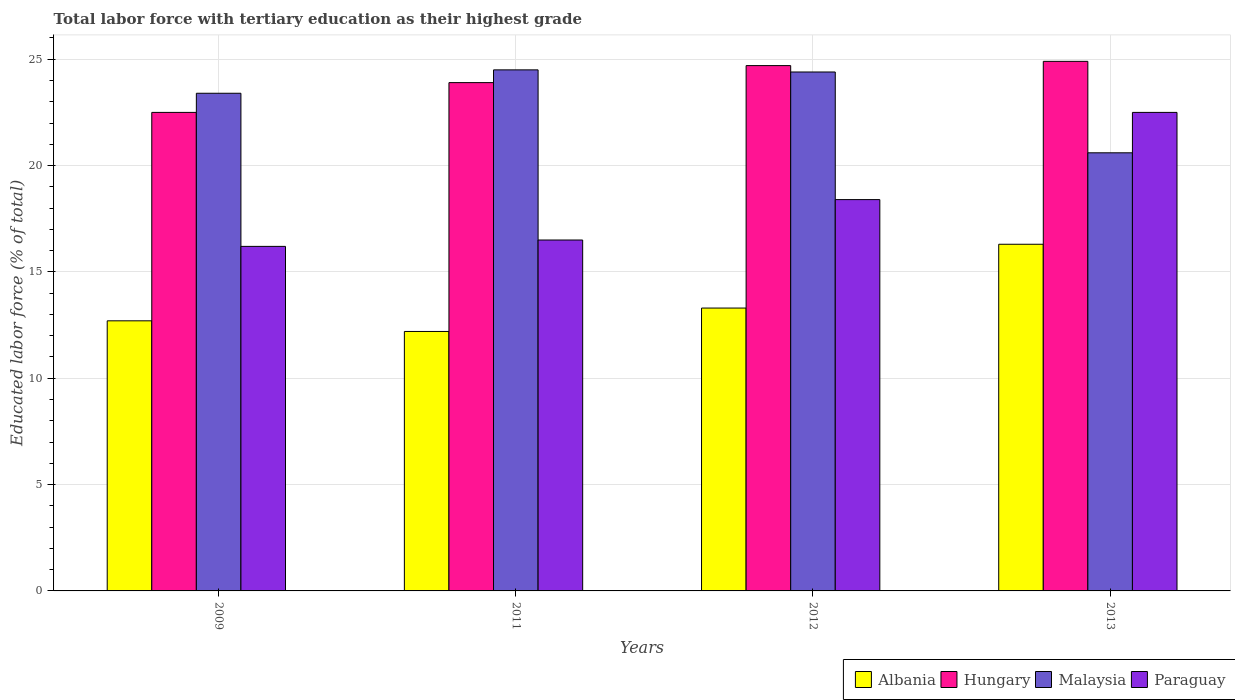How many different coloured bars are there?
Your answer should be very brief. 4. How many bars are there on the 3rd tick from the left?
Make the answer very short. 4. How many bars are there on the 1st tick from the right?
Give a very brief answer. 4. What is the label of the 2nd group of bars from the left?
Provide a short and direct response. 2011. What is the percentage of male labor force with tertiary education in Hungary in 2009?
Provide a succinct answer. 22.5. Across all years, what is the maximum percentage of male labor force with tertiary education in Hungary?
Your answer should be compact. 24.9. Across all years, what is the minimum percentage of male labor force with tertiary education in Albania?
Your response must be concise. 12.2. In which year was the percentage of male labor force with tertiary education in Hungary minimum?
Give a very brief answer. 2009. What is the total percentage of male labor force with tertiary education in Hungary in the graph?
Offer a very short reply. 96. What is the difference between the percentage of male labor force with tertiary education in Paraguay in 2011 and that in 2012?
Offer a very short reply. -1.9. What is the difference between the percentage of male labor force with tertiary education in Malaysia in 2009 and the percentage of male labor force with tertiary education in Albania in 2012?
Offer a terse response. 10.1. What is the average percentage of male labor force with tertiary education in Paraguay per year?
Keep it short and to the point. 18.4. In the year 2013, what is the difference between the percentage of male labor force with tertiary education in Hungary and percentage of male labor force with tertiary education in Malaysia?
Give a very brief answer. 4.3. What is the ratio of the percentage of male labor force with tertiary education in Hungary in 2011 to that in 2012?
Ensure brevity in your answer.  0.97. Is the percentage of male labor force with tertiary education in Hungary in 2011 less than that in 2013?
Keep it short and to the point. Yes. Is the difference between the percentage of male labor force with tertiary education in Hungary in 2009 and 2011 greater than the difference between the percentage of male labor force with tertiary education in Malaysia in 2009 and 2011?
Make the answer very short. No. What is the difference between the highest and the second highest percentage of male labor force with tertiary education in Hungary?
Provide a succinct answer. 0.2. What is the difference between the highest and the lowest percentage of male labor force with tertiary education in Albania?
Keep it short and to the point. 4.1. In how many years, is the percentage of male labor force with tertiary education in Paraguay greater than the average percentage of male labor force with tertiary education in Paraguay taken over all years?
Offer a very short reply. 1. What does the 2nd bar from the left in 2009 represents?
Provide a succinct answer. Hungary. What does the 3rd bar from the right in 2013 represents?
Your answer should be very brief. Hungary. How many bars are there?
Your response must be concise. 16. Are all the bars in the graph horizontal?
Provide a succinct answer. No. How many years are there in the graph?
Your answer should be very brief. 4. What is the difference between two consecutive major ticks on the Y-axis?
Provide a short and direct response. 5. Does the graph contain any zero values?
Give a very brief answer. No. How are the legend labels stacked?
Your response must be concise. Horizontal. What is the title of the graph?
Provide a succinct answer. Total labor force with tertiary education as their highest grade. Does "Croatia" appear as one of the legend labels in the graph?
Provide a succinct answer. No. What is the label or title of the Y-axis?
Provide a succinct answer. Educated labor force (% of total). What is the Educated labor force (% of total) in Albania in 2009?
Keep it short and to the point. 12.7. What is the Educated labor force (% of total) of Hungary in 2009?
Keep it short and to the point. 22.5. What is the Educated labor force (% of total) of Malaysia in 2009?
Provide a succinct answer. 23.4. What is the Educated labor force (% of total) in Paraguay in 2009?
Offer a very short reply. 16.2. What is the Educated labor force (% of total) in Albania in 2011?
Offer a very short reply. 12.2. What is the Educated labor force (% of total) of Hungary in 2011?
Provide a short and direct response. 23.9. What is the Educated labor force (% of total) of Malaysia in 2011?
Provide a succinct answer. 24.5. What is the Educated labor force (% of total) in Albania in 2012?
Your answer should be compact. 13.3. What is the Educated labor force (% of total) in Hungary in 2012?
Offer a very short reply. 24.7. What is the Educated labor force (% of total) in Malaysia in 2012?
Give a very brief answer. 24.4. What is the Educated labor force (% of total) in Paraguay in 2012?
Give a very brief answer. 18.4. What is the Educated labor force (% of total) in Albania in 2013?
Ensure brevity in your answer.  16.3. What is the Educated labor force (% of total) of Hungary in 2013?
Offer a terse response. 24.9. What is the Educated labor force (% of total) of Malaysia in 2013?
Your response must be concise. 20.6. Across all years, what is the maximum Educated labor force (% of total) in Albania?
Your response must be concise. 16.3. Across all years, what is the maximum Educated labor force (% of total) in Hungary?
Your answer should be compact. 24.9. Across all years, what is the minimum Educated labor force (% of total) of Albania?
Ensure brevity in your answer.  12.2. Across all years, what is the minimum Educated labor force (% of total) of Malaysia?
Provide a short and direct response. 20.6. Across all years, what is the minimum Educated labor force (% of total) of Paraguay?
Offer a terse response. 16.2. What is the total Educated labor force (% of total) in Albania in the graph?
Ensure brevity in your answer.  54.5. What is the total Educated labor force (% of total) of Hungary in the graph?
Provide a short and direct response. 96. What is the total Educated labor force (% of total) in Malaysia in the graph?
Your answer should be very brief. 92.9. What is the total Educated labor force (% of total) of Paraguay in the graph?
Ensure brevity in your answer.  73.6. What is the difference between the Educated labor force (% of total) of Hungary in 2009 and that in 2011?
Make the answer very short. -1.4. What is the difference between the Educated labor force (% of total) of Albania in 2009 and that in 2012?
Your answer should be very brief. -0.6. What is the difference between the Educated labor force (% of total) in Paraguay in 2009 and that in 2013?
Ensure brevity in your answer.  -6.3. What is the difference between the Educated labor force (% of total) in Albania in 2011 and that in 2012?
Your answer should be very brief. -1.1. What is the difference between the Educated labor force (% of total) in Hungary in 2011 and that in 2012?
Ensure brevity in your answer.  -0.8. What is the difference between the Educated labor force (% of total) of Paraguay in 2011 and that in 2012?
Provide a short and direct response. -1.9. What is the difference between the Educated labor force (% of total) in Albania in 2011 and that in 2013?
Offer a very short reply. -4.1. What is the difference between the Educated labor force (% of total) of Hungary in 2011 and that in 2013?
Your response must be concise. -1. What is the difference between the Educated labor force (% of total) in Malaysia in 2011 and that in 2013?
Ensure brevity in your answer.  3.9. What is the difference between the Educated labor force (% of total) in Paraguay in 2011 and that in 2013?
Give a very brief answer. -6. What is the difference between the Educated labor force (% of total) in Albania in 2012 and that in 2013?
Give a very brief answer. -3. What is the difference between the Educated labor force (% of total) in Malaysia in 2012 and that in 2013?
Your response must be concise. 3.8. What is the difference between the Educated labor force (% of total) in Albania in 2009 and the Educated labor force (% of total) in Hungary in 2011?
Offer a terse response. -11.2. What is the difference between the Educated labor force (% of total) in Albania in 2009 and the Educated labor force (% of total) in Malaysia in 2011?
Ensure brevity in your answer.  -11.8. What is the difference between the Educated labor force (% of total) of Albania in 2009 and the Educated labor force (% of total) of Paraguay in 2011?
Your answer should be very brief. -3.8. What is the difference between the Educated labor force (% of total) of Hungary in 2009 and the Educated labor force (% of total) of Malaysia in 2011?
Offer a very short reply. -2. What is the difference between the Educated labor force (% of total) in Malaysia in 2009 and the Educated labor force (% of total) in Paraguay in 2011?
Ensure brevity in your answer.  6.9. What is the difference between the Educated labor force (% of total) in Albania in 2009 and the Educated labor force (% of total) in Paraguay in 2012?
Offer a terse response. -5.7. What is the difference between the Educated labor force (% of total) in Hungary in 2009 and the Educated labor force (% of total) in Malaysia in 2012?
Your answer should be very brief. -1.9. What is the difference between the Educated labor force (% of total) in Hungary in 2009 and the Educated labor force (% of total) in Paraguay in 2012?
Your answer should be very brief. 4.1. What is the difference between the Educated labor force (% of total) of Albania in 2009 and the Educated labor force (% of total) of Malaysia in 2013?
Your answer should be very brief. -7.9. What is the difference between the Educated labor force (% of total) of Albania in 2011 and the Educated labor force (% of total) of Malaysia in 2012?
Offer a terse response. -12.2. What is the difference between the Educated labor force (% of total) in Albania in 2011 and the Educated labor force (% of total) in Paraguay in 2012?
Your answer should be very brief. -6.2. What is the difference between the Educated labor force (% of total) of Hungary in 2011 and the Educated labor force (% of total) of Malaysia in 2012?
Your answer should be very brief. -0.5. What is the difference between the Educated labor force (% of total) in Hungary in 2011 and the Educated labor force (% of total) in Malaysia in 2013?
Make the answer very short. 3.3. What is the difference between the Educated labor force (% of total) of Hungary in 2011 and the Educated labor force (% of total) of Paraguay in 2013?
Offer a terse response. 1.4. What is the difference between the Educated labor force (% of total) of Albania in 2012 and the Educated labor force (% of total) of Hungary in 2013?
Offer a very short reply. -11.6. What is the difference between the Educated labor force (% of total) in Albania in 2012 and the Educated labor force (% of total) in Malaysia in 2013?
Your answer should be very brief. -7.3. What is the difference between the Educated labor force (% of total) of Albania in 2012 and the Educated labor force (% of total) of Paraguay in 2013?
Provide a short and direct response. -9.2. What is the difference between the Educated labor force (% of total) of Hungary in 2012 and the Educated labor force (% of total) of Malaysia in 2013?
Your response must be concise. 4.1. What is the difference between the Educated labor force (% of total) in Hungary in 2012 and the Educated labor force (% of total) in Paraguay in 2013?
Your answer should be compact. 2.2. What is the difference between the Educated labor force (% of total) of Malaysia in 2012 and the Educated labor force (% of total) of Paraguay in 2013?
Provide a short and direct response. 1.9. What is the average Educated labor force (% of total) in Albania per year?
Provide a succinct answer. 13.62. What is the average Educated labor force (% of total) of Malaysia per year?
Provide a short and direct response. 23.23. What is the average Educated labor force (% of total) of Paraguay per year?
Provide a short and direct response. 18.4. In the year 2009, what is the difference between the Educated labor force (% of total) in Albania and Educated labor force (% of total) in Hungary?
Make the answer very short. -9.8. In the year 2009, what is the difference between the Educated labor force (% of total) of Albania and Educated labor force (% of total) of Paraguay?
Provide a short and direct response. -3.5. In the year 2009, what is the difference between the Educated labor force (% of total) in Hungary and Educated labor force (% of total) in Malaysia?
Your answer should be compact. -0.9. In the year 2009, what is the difference between the Educated labor force (% of total) of Hungary and Educated labor force (% of total) of Paraguay?
Your answer should be very brief. 6.3. In the year 2009, what is the difference between the Educated labor force (% of total) in Malaysia and Educated labor force (% of total) in Paraguay?
Keep it short and to the point. 7.2. In the year 2011, what is the difference between the Educated labor force (% of total) of Albania and Educated labor force (% of total) of Hungary?
Offer a terse response. -11.7. In the year 2011, what is the difference between the Educated labor force (% of total) of Hungary and Educated labor force (% of total) of Malaysia?
Offer a terse response. -0.6. In the year 2012, what is the difference between the Educated labor force (% of total) of Albania and Educated labor force (% of total) of Malaysia?
Your answer should be very brief. -11.1. In the year 2013, what is the difference between the Educated labor force (% of total) in Hungary and Educated labor force (% of total) in Malaysia?
Make the answer very short. 4.3. In the year 2013, what is the difference between the Educated labor force (% of total) of Hungary and Educated labor force (% of total) of Paraguay?
Give a very brief answer. 2.4. What is the ratio of the Educated labor force (% of total) in Albania in 2009 to that in 2011?
Give a very brief answer. 1.04. What is the ratio of the Educated labor force (% of total) of Hungary in 2009 to that in 2011?
Ensure brevity in your answer.  0.94. What is the ratio of the Educated labor force (% of total) of Malaysia in 2009 to that in 2011?
Your answer should be compact. 0.96. What is the ratio of the Educated labor force (% of total) of Paraguay in 2009 to that in 2011?
Make the answer very short. 0.98. What is the ratio of the Educated labor force (% of total) in Albania in 2009 to that in 2012?
Ensure brevity in your answer.  0.95. What is the ratio of the Educated labor force (% of total) of Hungary in 2009 to that in 2012?
Provide a short and direct response. 0.91. What is the ratio of the Educated labor force (% of total) of Malaysia in 2009 to that in 2012?
Keep it short and to the point. 0.96. What is the ratio of the Educated labor force (% of total) of Paraguay in 2009 to that in 2012?
Ensure brevity in your answer.  0.88. What is the ratio of the Educated labor force (% of total) of Albania in 2009 to that in 2013?
Provide a succinct answer. 0.78. What is the ratio of the Educated labor force (% of total) in Hungary in 2009 to that in 2013?
Offer a terse response. 0.9. What is the ratio of the Educated labor force (% of total) of Malaysia in 2009 to that in 2013?
Offer a very short reply. 1.14. What is the ratio of the Educated labor force (% of total) of Paraguay in 2009 to that in 2013?
Offer a very short reply. 0.72. What is the ratio of the Educated labor force (% of total) in Albania in 2011 to that in 2012?
Offer a terse response. 0.92. What is the ratio of the Educated labor force (% of total) in Hungary in 2011 to that in 2012?
Make the answer very short. 0.97. What is the ratio of the Educated labor force (% of total) of Malaysia in 2011 to that in 2012?
Provide a succinct answer. 1. What is the ratio of the Educated labor force (% of total) in Paraguay in 2011 to that in 2012?
Provide a short and direct response. 0.9. What is the ratio of the Educated labor force (% of total) of Albania in 2011 to that in 2013?
Ensure brevity in your answer.  0.75. What is the ratio of the Educated labor force (% of total) in Hungary in 2011 to that in 2013?
Your response must be concise. 0.96. What is the ratio of the Educated labor force (% of total) of Malaysia in 2011 to that in 2013?
Your response must be concise. 1.19. What is the ratio of the Educated labor force (% of total) of Paraguay in 2011 to that in 2013?
Give a very brief answer. 0.73. What is the ratio of the Educated labor force (% of total) of Albania in 2012 to that in 2013?
Offer a terse response. 0.82. What is the ratio of the Educated labor force (% of total) in Hungary in 2012 to that in 2013?
Provide a short and direct response. 0.99. What is the ratio of the Educated labor force (% of total) of Malaysia in 2012 to that in 2013?
Offer a terse response. 1.18. What is the ratio of the Educated labor force (% of total) of Paraguay in 2012 to that in 2013?
Your answer should be compact. 0.82. What is the difference between the highest and the lowest Educated labor force (% of total) in Albania?
Provide a short and direct response. 4.1. What is the difference between the highest and the lowest Educated labor force (% of total) of Hungary?
Provide a short and direct response. 2.4. What is the difference between the highest and the lowest Educated labor force (% of total) of Malaysia?
Keep it short and to the point. 3.9. What is the difference between the highest and the lowest Educated labor force (% of total) of Paraguay?
Give a very brief answer. 6.3. 